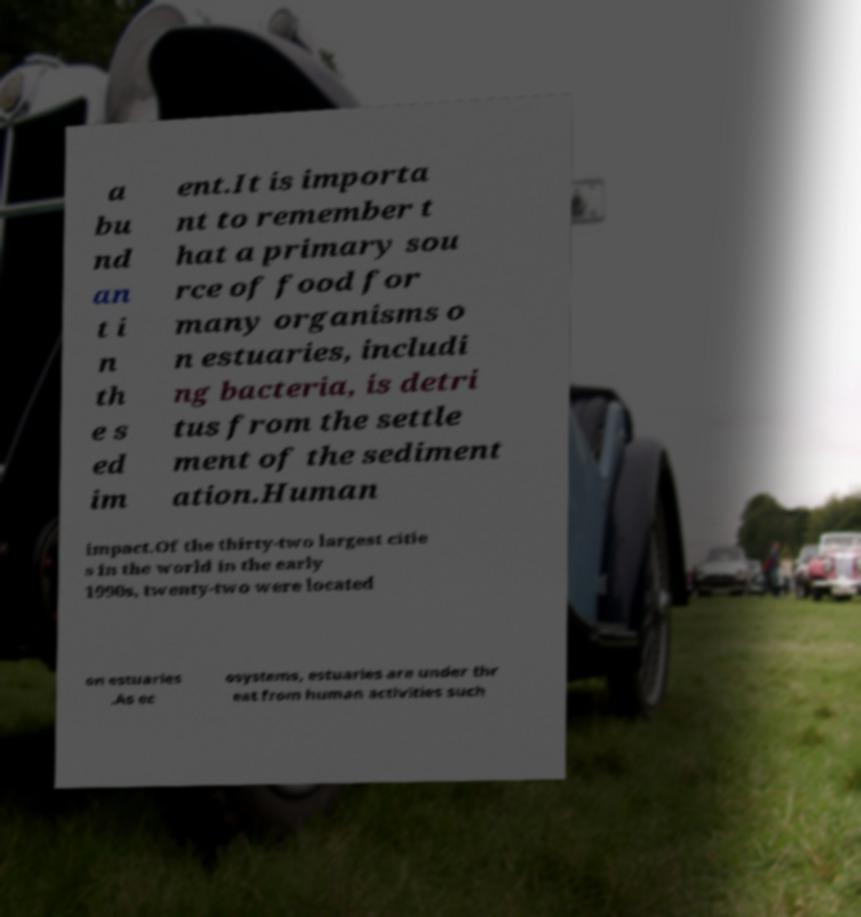What messages or text are displayed in this image? I need them in a readable, typed format. a bu nd an t i n th e s ed im ent.It is importa nt to remember t hat a primary sou rce of food for many organisms o n estuaries, includi ng bacteria, is detri tus from the settle ment of the sediment ation.Human impact.Of the thirty-two largest citie s in the world in the early 1990s, twenty-two were located on estuaries .As ec osystems, estuaries are under thr eat from human activities such 